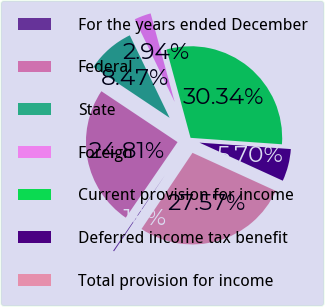Convert chart. <chart><loc_0><loc_0><loc_500><loc_500><pie_chart><fcel>For the years ended December<fcel>Federal<fcel>State<fcel>Foreign<fcel>Current provision for income<fcel>Deferred income tax benefit<fcel>Total provision for income<nl><fcel>0.18%<fcel>24.81%<fcel>8.47%<fcel>2.94%<fcel>30.34%<fcel>5.7%<fcel>27.57%<nl></chart> 